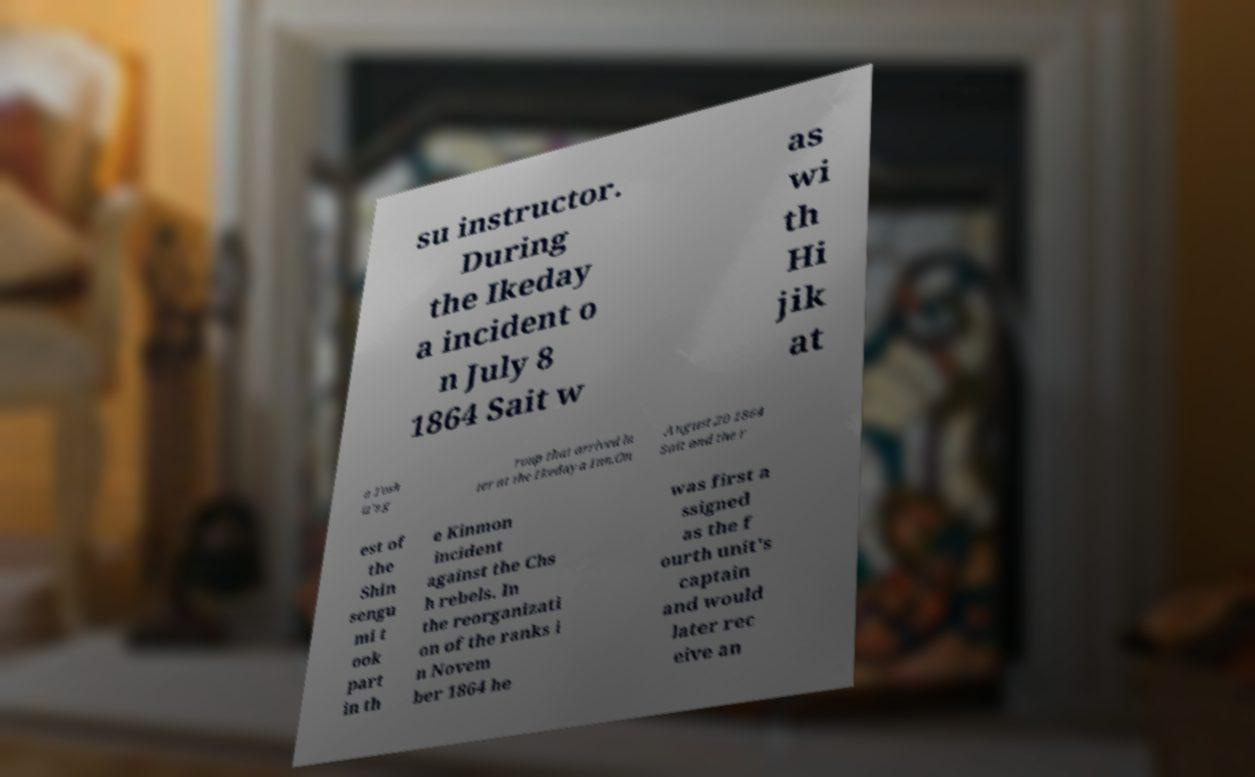I need the written content from this picture converted into text. Can you do that? su instructor. During the Ikeday a incident o n July 8 1864 Sait w as wi th Hi jik at a Tosh iz's g roup that arrived la ter at the Ikedaya Inn.On August 20 1864 Sait and the r est of the Shin sengu mi t ook part in th e Kinmon incident against the Chs h rebels. In the reorganizati on of the ranks i n Novem ber 1864 he was first a ssigned as the f ourth unit's captain and would later rec eive an 